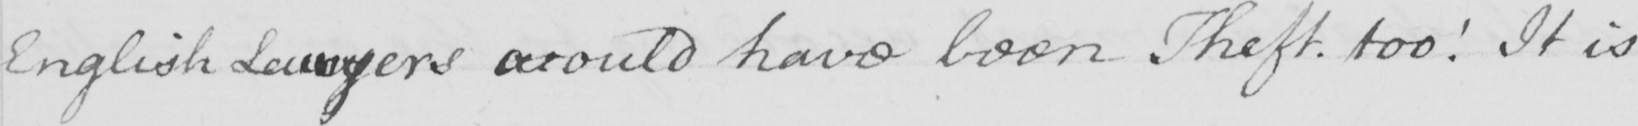Can you read and transcribe this handwriting? English Lawyers would have been Theft . too !  It is 